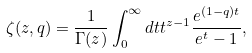<formula> <loc_0><loc_0><loc_500><loc_500>\zeta ( z , q ) = \frac { 1 } { \Gamma ( z ) } \int _ { 0 } ^ { \infty } d t t ^ { z - 1 } \frac { e ^ { ( 1 - q ) t } } { e ^ { t } - 1 } ,</formula> 